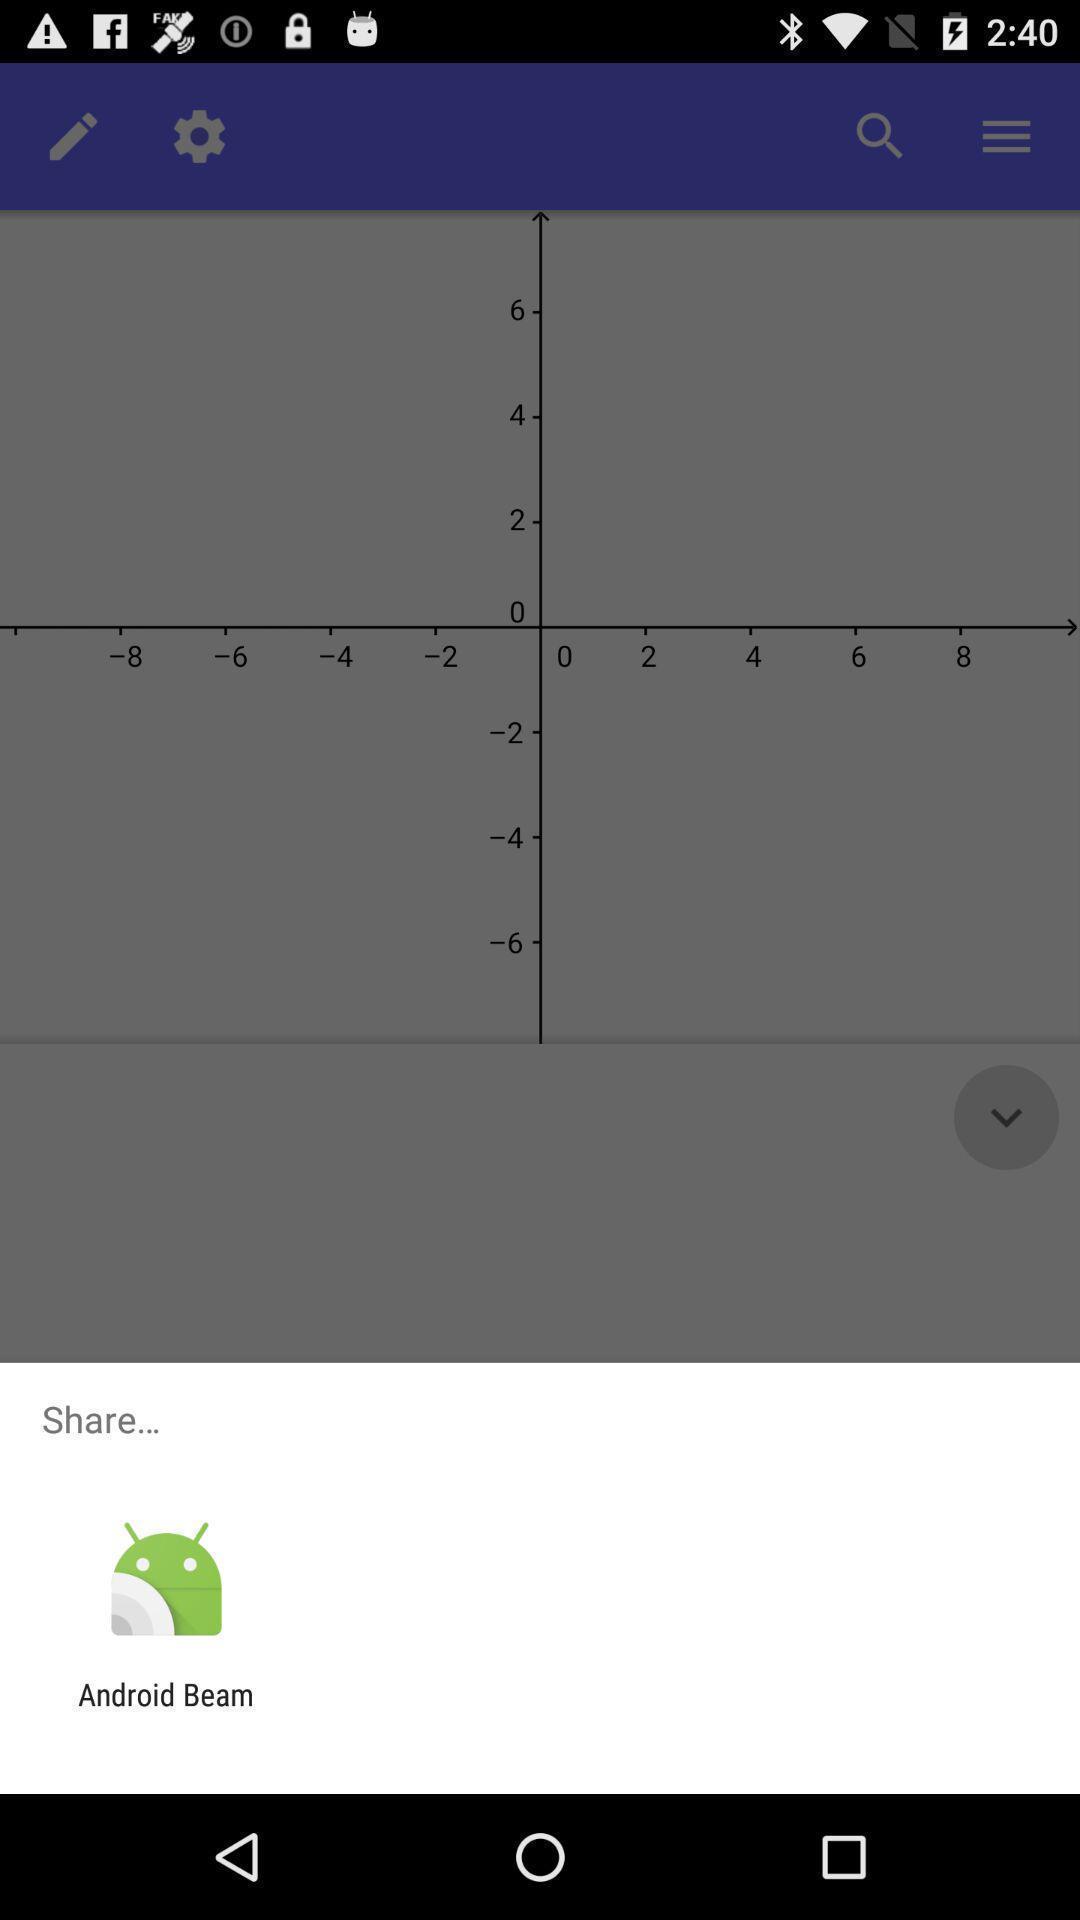Tell me about the visual elements in this screen capture. Push up message displaying to share via application. 